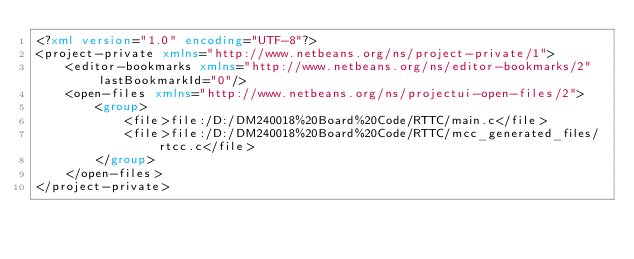Convert code to text. <code><loc_0><loc_0><loc_500><loc_500><_XML_><?xml version="1.0" encoding="UTF-8"?>
<project-private xmlns="http://www.netbeans.org/ns/project-private/1">
    <editor-bookmarks xmlns="http://www.netbeans.org/ns/editor-bookmarks/2" lastBookmarkId="0"/>
    <open-files xmlns="http://www.netbeans.org/ns/projectui-open-files/2">
        <group>
            <file>file:/D:/DM240018%20Board%20Code/RTTC/main.c</file>
            <file>file:/D:/DM240018%20Board%20Code/RTTC/mcc_generated_files/rtcc.c</file>
        </group>
    </open-files>
</project-private>
</code> 